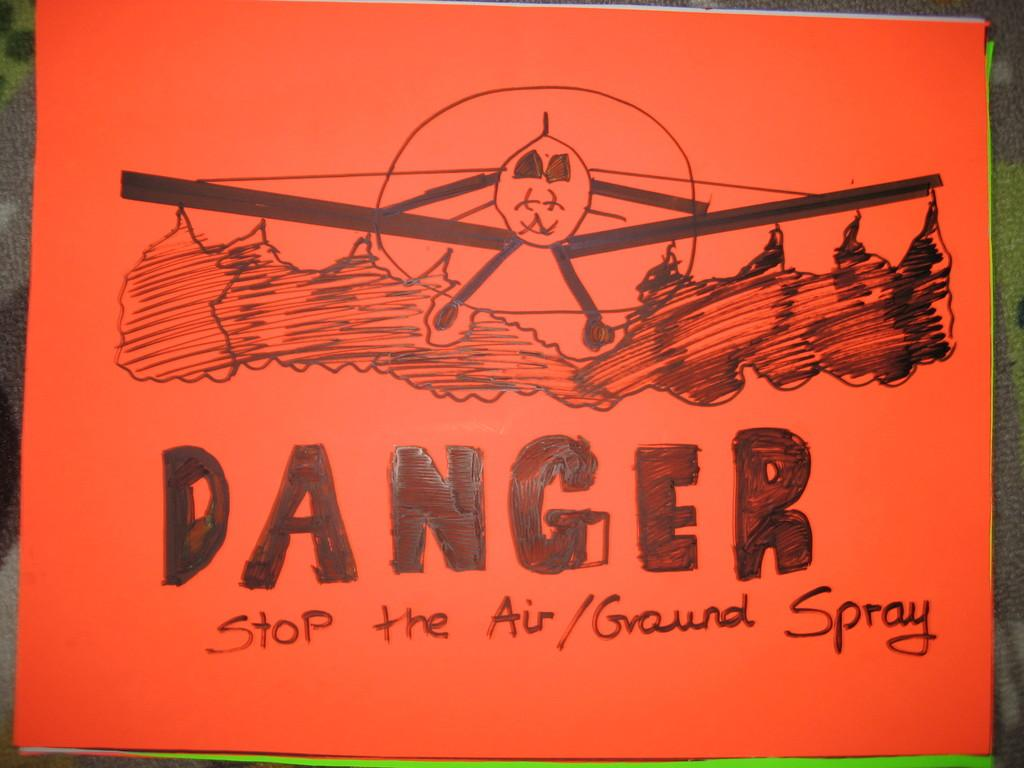Provide a one-sentence caption for the provided image. A hand draw poster bears a picture of an aeroplane spraying the ground with the word Danger writ large below it. 